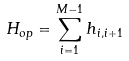Convert formula to latex. <formula><loc_0><loc_0><loc_500><loc_500>H _ { o p } = \sum _ { i = 1 } ^ { M - 1 } h _ { i , i + 1 }</formula> 